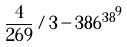<formula> <loc_0><loc_0><loc_500><loc_500>\frac { 4 } { 2 6 9 } / 3 - { 3 8 6 ^ { 3 8 } } ^ { 9 }</formula> 